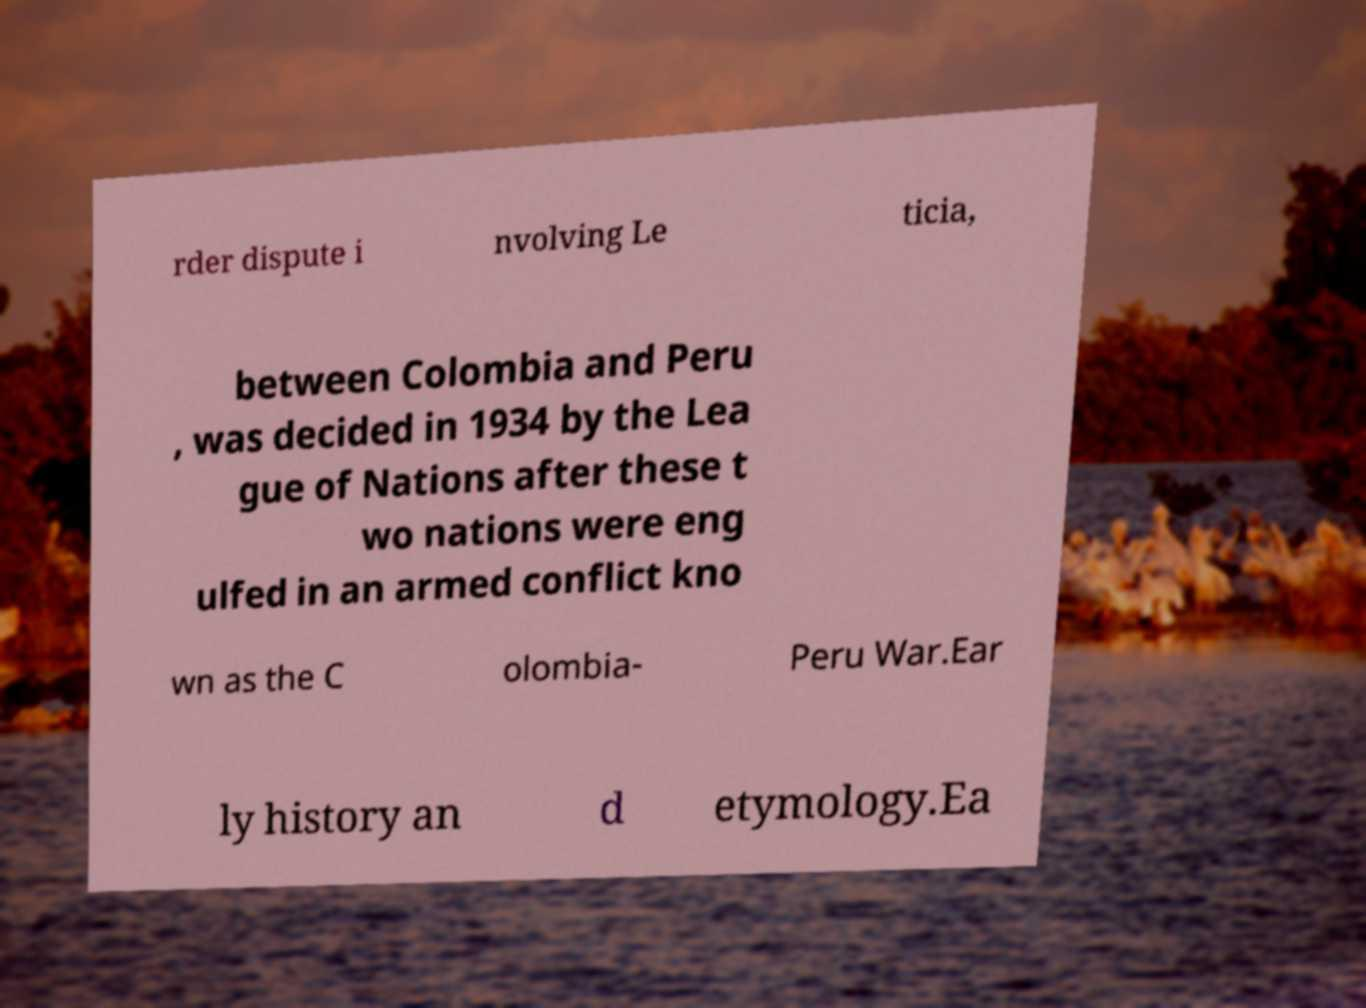Could you extract and type out the text from this image? rder dispute i nvolving Le ticia, between Colombia and Peru , was decided in 1934 by the Lea gue of Nations after these t wo nations were eng ulfed in an armed conflict kno wn as the C olombia- Peru War.Ear ly history an d etymology.Ea 